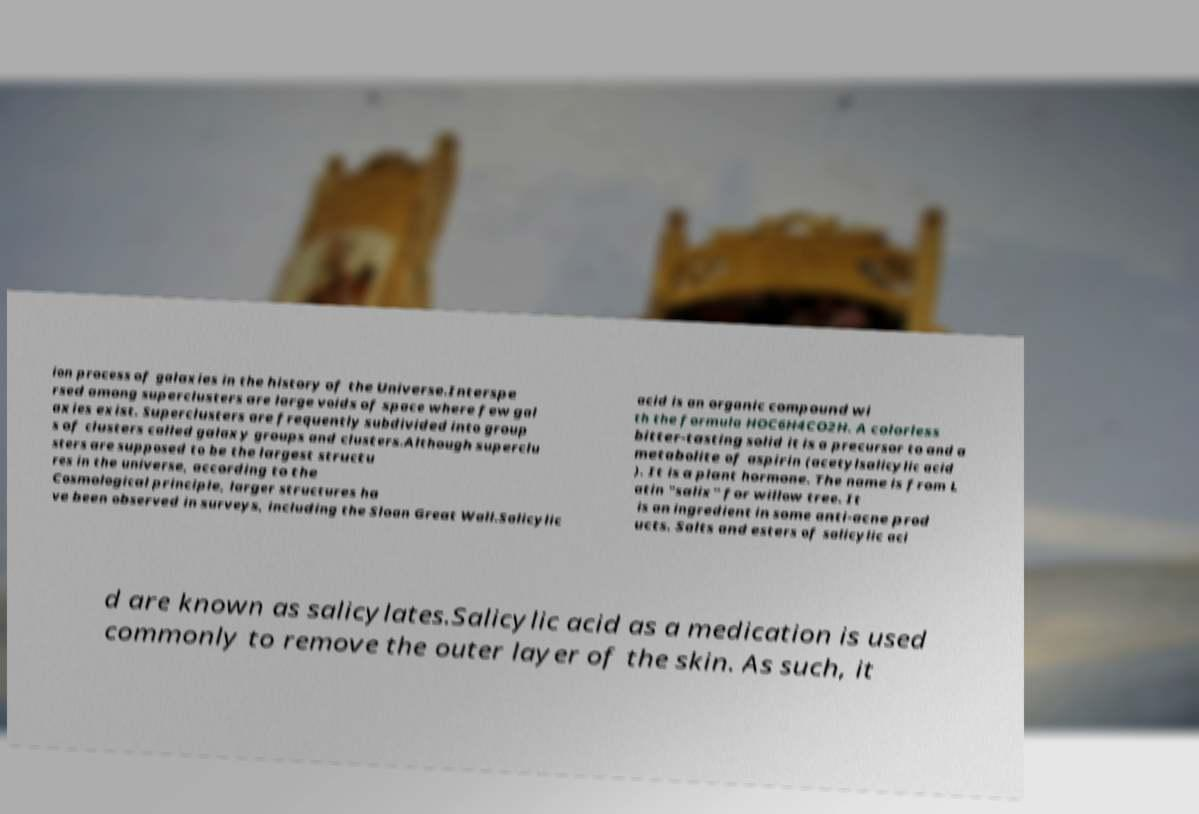Can you accurately transcribe the text from the provided image for me? ion process of galaxies in the history of the Universe.Interspe rsed among superclusters are large voids of space where few gal axies exist. Superclusters are frequently subdivided into group s of clusters called galaxy groups and clusters.Although superclu sters are supposed to be the largest structu res in the universe, according to the Cosmological principle, larger structures ha ve been observed in surveys, including the Sloan Great Wall.Salicylic acid is an organic compound wi th the formula HOC6H4CO2H. A colorless bitter-tasting solid it is a precursor to and a metabolite of aspirin (acetylsalicylic acid ). It is a plant hormone. The name is from L atin "salix" for willow tree. It is an ingredient in some anti-acne prod ucts. Salts and esters of salicylic aci d are known as salicylates.Salicylic acid as a medication is used commonly to remove the outer layer of the skin. As such, it 